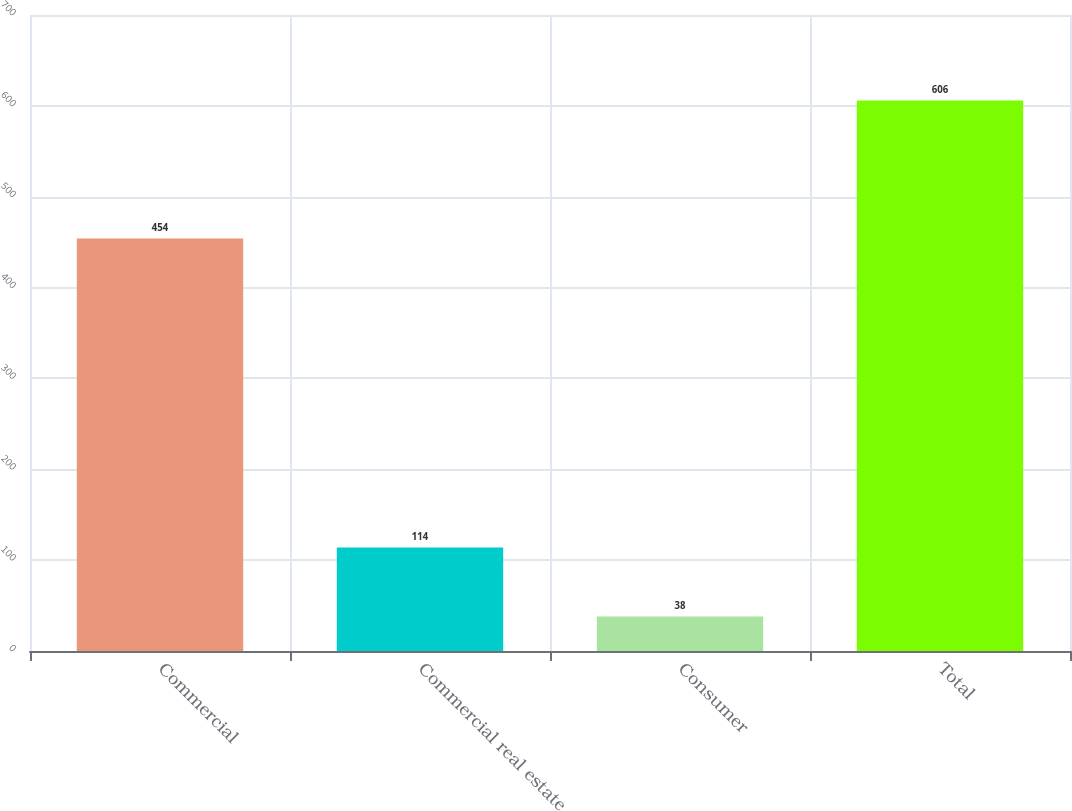Convert chart to OTSL. <chart><loc_0><loc_0><loc_500><loc_500><bar_chart><fcel>Commercial<fcel>Commercial real estate<fcel>Consumer<fcel>Total<nl><fcel>454<fcel>114<fcel>38<fcel>606<nl></chart> 